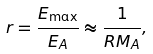<formula> <loc_0><loc_0><loc_500><loc_500>r = \frac { E _ { \max } } { E _ { A } } \approx \frac { 1 } { R M _ { A } } ,</formula> 